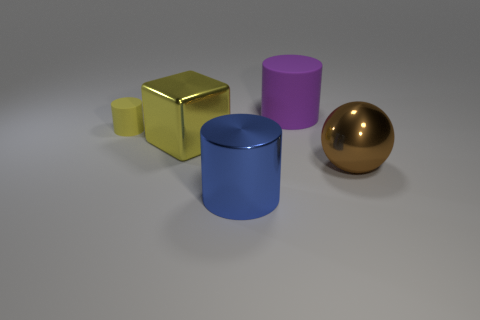Subtract all large purple cylinders. How many cylinders are left? 2 Add 4 large gray metal blocks. How many objects exist? 9 Subtract all blue cylinders. How many cylinders are left? 2 Subtract 1 cylinders. How many cylinders are left? 2 Subtract all purple spheres. Subtract all red cylinders. How many spheres are left? 1 Subtract all cubes. How many objects are left? 4 Subtract all tiny yellow matte objects. Subtract all large shiny cubes. How many objects are left? 3 Add 5 large yellow things. How many large yellow things are left? 6 Add 2 purple cylinders. How many purple cylinders exist? 3 Subtract 0 red spheres. How many objects are left? 5 